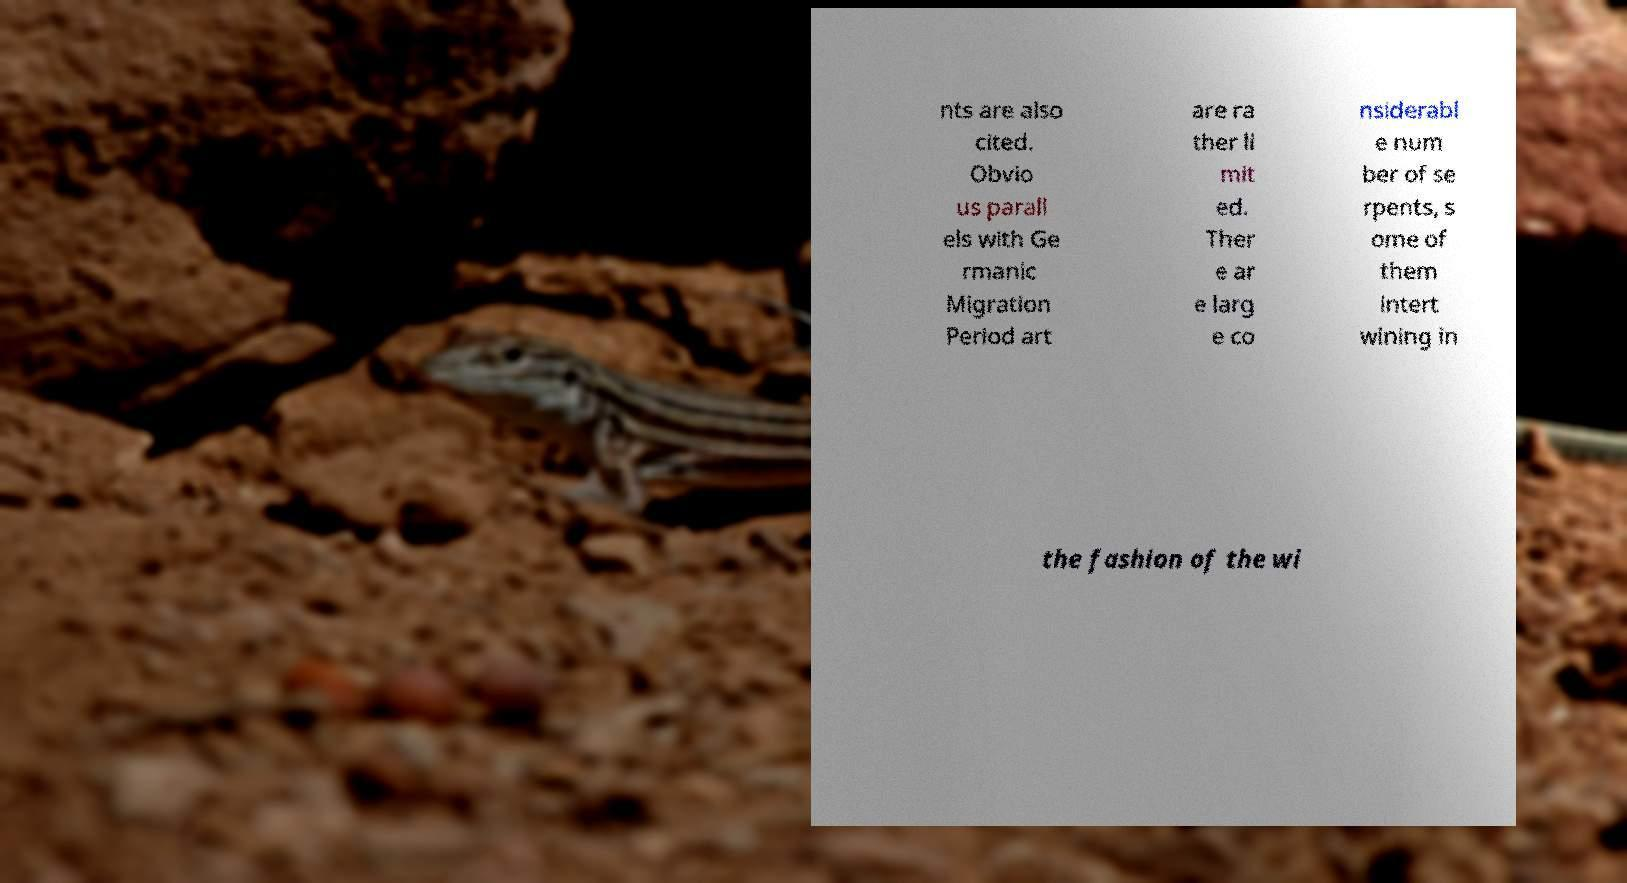For documentation purposes, I need the text within this image transcribed. Could you provide that? nts are also cited. Obvio us parall els with Ge rmanic Migration Period art are ra ther li mit ed. Ther e ar e larg e co nsiderabl e num ber of se rpents, s ome of them intert wining in the fashion of the wi 